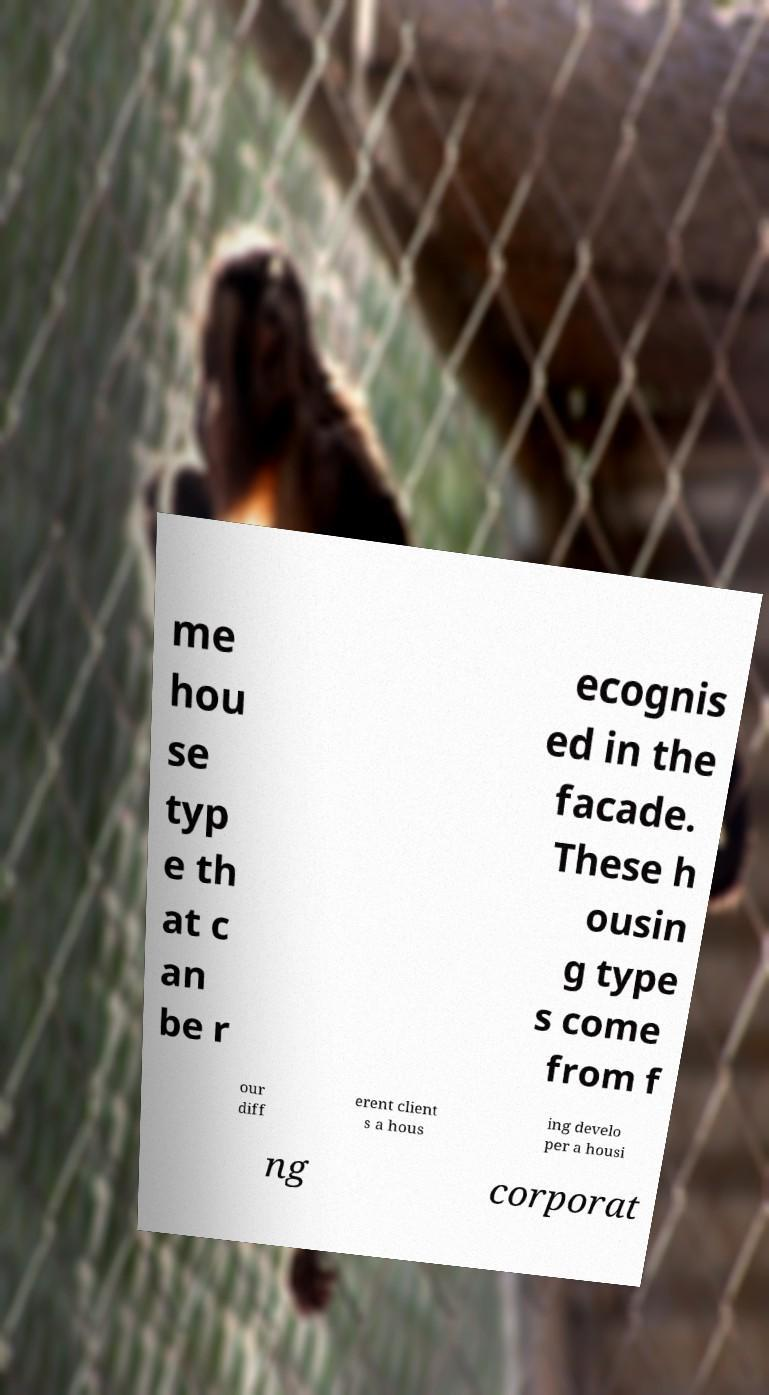Could you assist in decoding the text presented in this image and type it out clearly? me hou se typ e th at c an be r ecognis ed in the facade. These h ousin g type s come from f our diff erent client s a hous ing develo per a housi ng corporat 